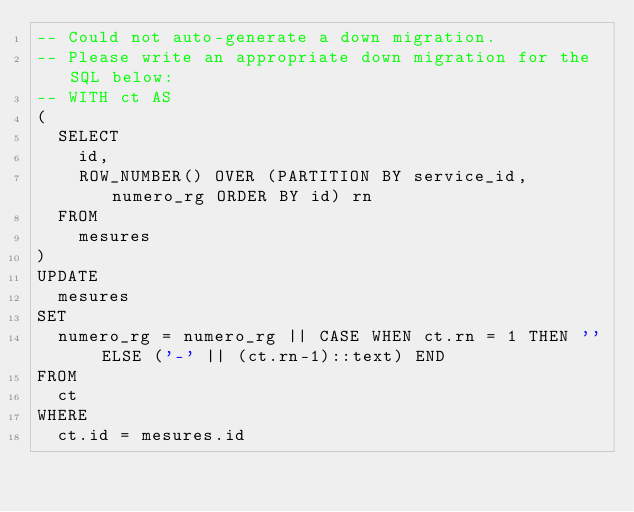<code> <loc_0><loc_0><loc_500><loc_500><_SQL_>-- Could not auto-generate a down migration.
-- Please write an appropriate down migration for the SQL below:
-- WITH ct AS
(
  SELECT
    id,
    ROW_NUMBER() OVER (PARTITION BY service_id, numero_rg ORDER BY id) rn
  FROM
    mesures
)
UPDATE
  mesures
SET
  numero_rg = numero_rg || CASE WHEN ct.rn = 1 THEN '' ELSE ('-' || (ct.rn-1)::text) END
FROM
  ct
WHERE
  ct.id = mesures.id</code> 